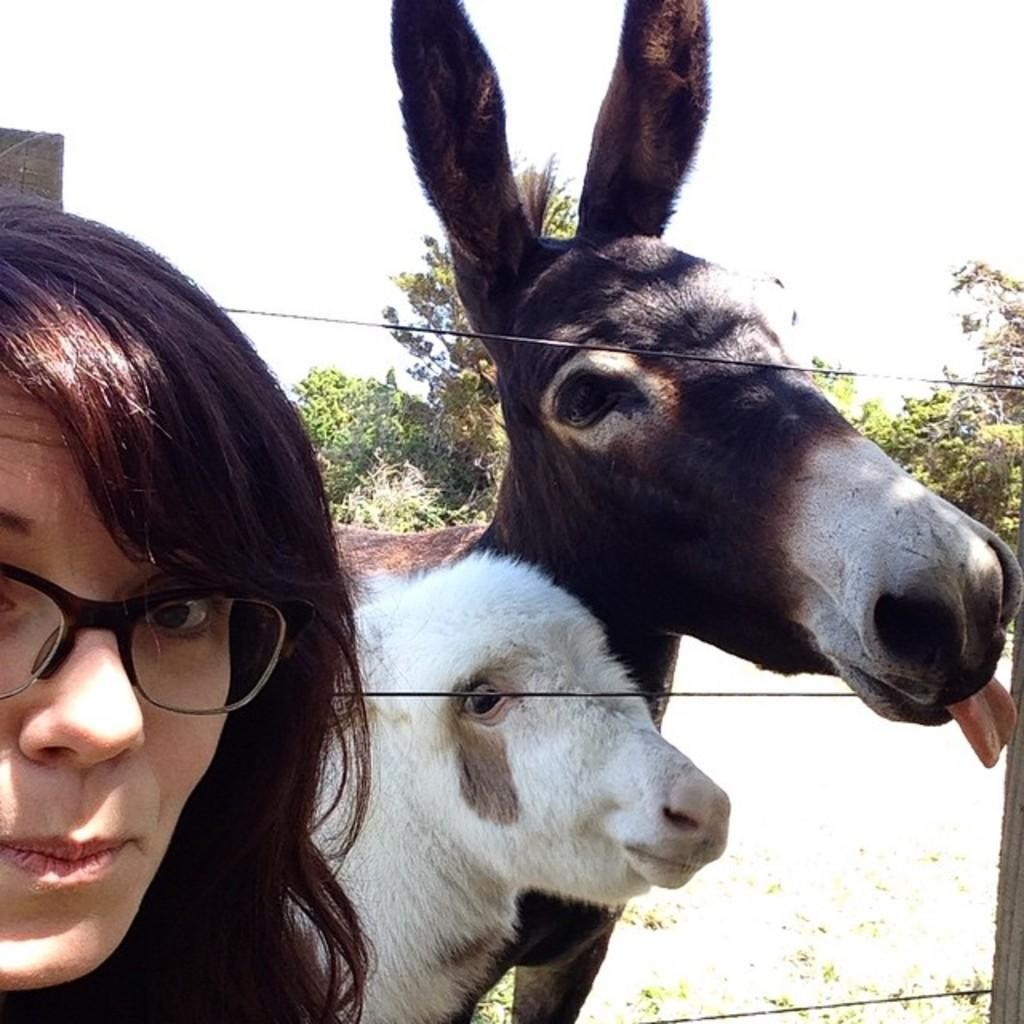Who or what is present in the image? There is a person and two donkeys in the image. What are the donkeys doing in the image? The donkeys are standing in front of a wooden fence. What can be seen in the background of the image? There are trees and the sky visible in the background of the image. What type of jelly is being sold by the person in the image? There is no jelly present in the image, nor is there any indication that the person is selling anything. What is the profit margin for the business in the image? There is no business present in the image, so it is impossible to determine the profit margin. 